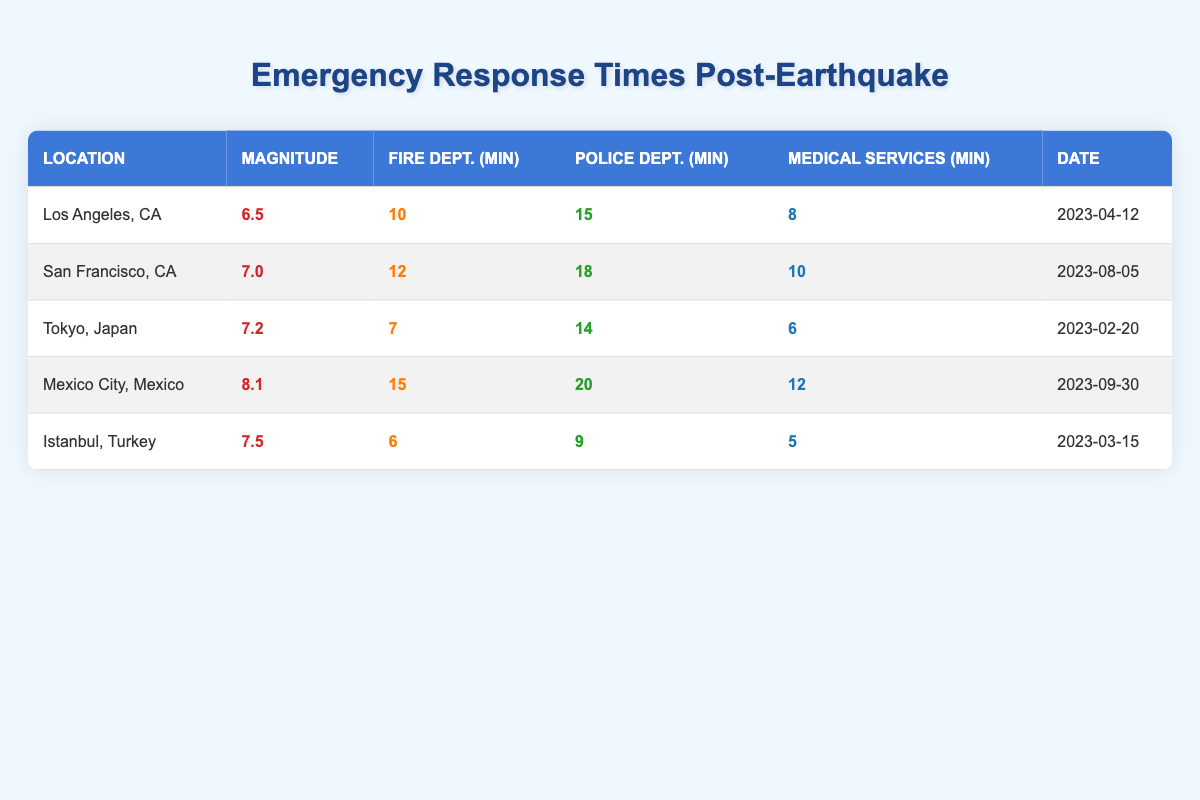What was the fastest response time for Fire Department services? The Fire Department had the fastest response time of 6 minutes, which occurred in Istanbul, Turkey.
Answer: 6 minutes What was the average response time for Medical Services across all locations? To find the average response time for Medical Services, we take the values (8, 10, 6, 12, 5) and sum them: 8 + 10 + 6 + 12 + 5 = 41. Then we divide by the number of entries (5): 41 / 5 = 8.2. The average response time is approximately 8 minutes when rounded.
Answer: Approximately 8 minutes Did the Police Department have a longer response time in San Francisco compared to Los Angeles? In the table, the response time for the Police Department in San Francisco is 18 minutes, while in Los Angeles, it is 15 minutes. Since 18 is greater than 15, the statement is true.
Answer: Yes Which earthquake location had the longest average overall response time for emergency services? To determine this, we calculate the average response times for each location. Los Angeles: (10 + 15 + 8) / 3 = 11, San Francisco: (12 + 18 + 10) / 3 = 13.33, Tokyo: (7 + 14 + 6) / 3 = 9, Mexico City: (15 + 20 + 12) / 3 = 15.67, Istanbul: (6 + 9 + 5) / 3 = 6.67. The location with the longest average is Mexico City at 15.67 minutes.
Answer: Mexico City What is the difference in response time between the Fire Department in Mexico City and that in Tokyo? The Fire Department's response time in Mexico City is 15 minutes and in Tokyo is 7 minutes. To find the difference, we subtract: 15 - 7 = 8.
Answer: 8 minutes 